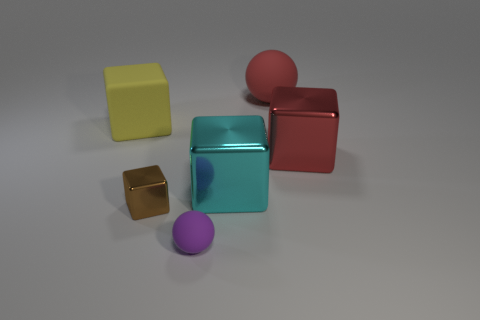Subtract all blue blocks. Subtract all gray cylinders. How many blocks are left? 4 Add 1 yellow cubes. How many objects exist? 7 Subtract all cubes. How many objects are left? 2 Add 2 large metal things. How many large metal things are left? 4 Add 1 large yellow rubber blocks. How many large yellow rubber blocks exist? 2 Subtract 0 blue cylinders. How many objects are left? 6 Subtract all small brown metallic cubes. Subtract all tiny brown metal things. How many objects are left? 4 